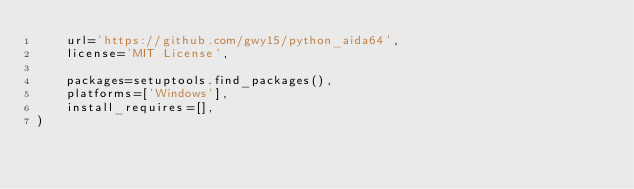<code> <loc_0><loc_0><loc_500><loc_500><_Python_>    url='https://github.com/gwy15/python_aida64',
    license='MIT License',

    packages=setuptools.find_packages(),
    platforms=['Windows'],
    install_requires=[],
)
</code> 